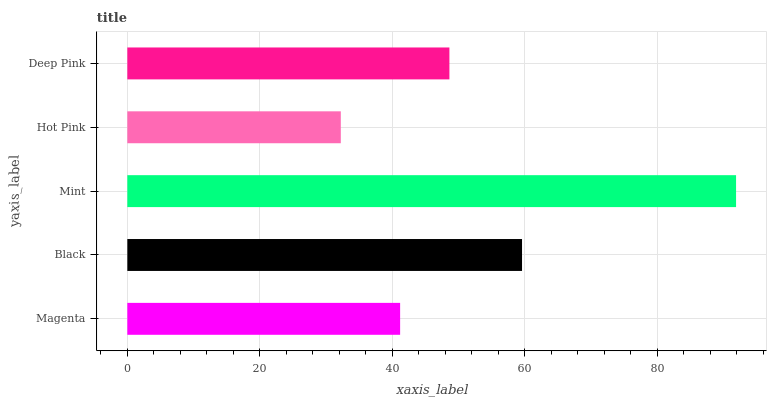Is Hot Pink the minimum?
Answer yes or no. Yes. Is Mint the maximum?
Answer yes or no. Yes. Is Black the minimum?
Answer yes or no. No. Is Black the maximum?
Answer yes or no. No. Is Black greater than Magenta?
Answer yes or no. Yes. Is Magenta less than Black?
Answer yes or no. Yes. Is Magenta greater than Black?
Answer yes or no. No. Is Black less than Magenta?
Answer yes or no. No. Is Deep Pink the high median?
Answer yes or no. Yes. Is Deep Pink the low median?
Answer yes or no. Yes. Is Hot Pink the high median?
Answer yes or no. No. Is Magenta the low median?
Answer yes or no. No. 